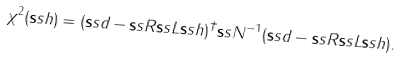Convert formula to latex. <formula><loc_0><loc_0><loc_500><loc_500>\chi ^ { 2 } ( { \mathbf s s h } ) = ( { \mathbf s s d } - { \mathbf s s R } { \mathbf s s L } { \mathbf s s h } ) ^ { \dagger } { \mathbf s s N } ^ { - 1 } ( { \mathbf s s d } - { \mathbf s s R } { \mathbf s s L } { \mathbf s s h } ) .</formula> 